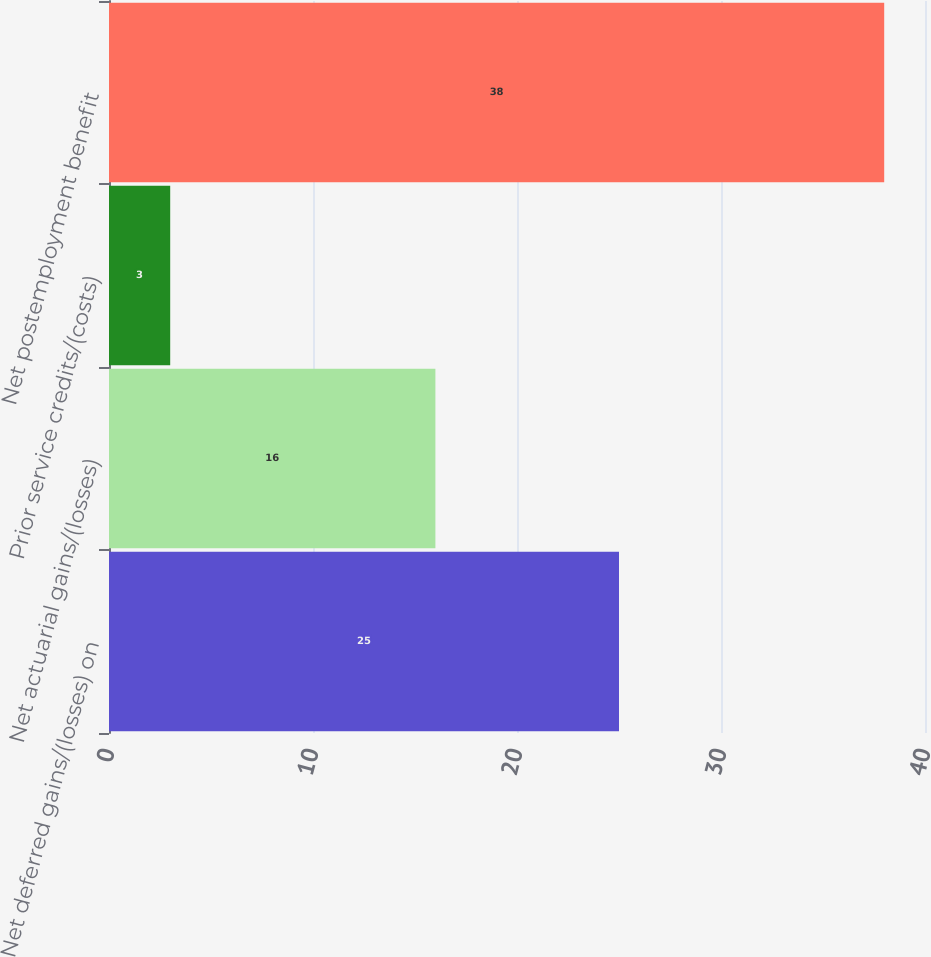Convert chart to OTSL. <chart><loc_0><loc_0><loc_500><loc_500><bar_chart><fcel>Net deferred gains/(losses) on<fcel>Net actuarial gains/(losses)<fcel>Prior service credits/(costs)<fcel>Net postemployment benefit<nl><fcel>25<fcel>16<fcel>3<fcel>38<nl></chart> 